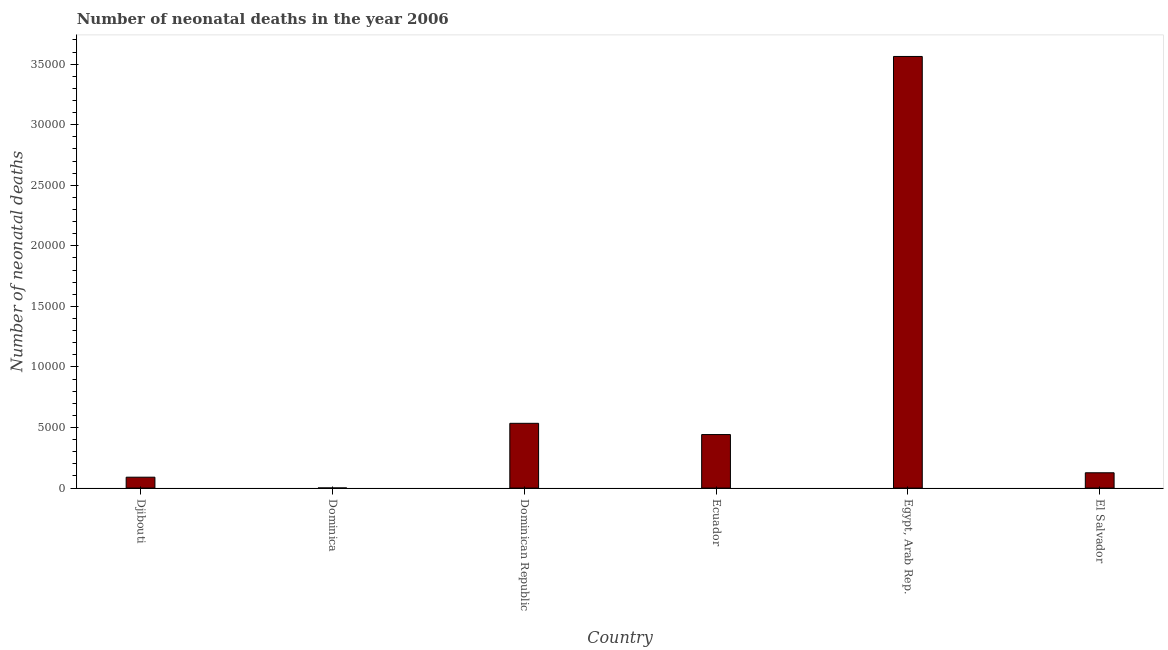Does the graph contain any zero values?
Your response must be concise. No. Does the graph contain grids?
Give a very brief answer. No. What is the title of the graph?
Your answer should be compact. Number of neonatal deaths in the year 2006. What is the label or title of the X-axis?
Make the answer very short. Country. What is the label or title of the Y-axis?
Keep it short and to the point. Number of neonatal deaths. What is the number of neonatal deaths in Dominican Republic?
Your answer should be compact. 5347. Across all countries, what is the maximum number of neonatal deaths?
Keep it short and to the point. 3.56e+04. Across all countries, what is the minimum number of neonatal deaths?
Give a very brief answer. 11. In which country was the number of neonatal deaths maximum?
Make the answer very short. Egypt, Arab Rep. In which country was the number of neonatal deaths minimum?
Offer a terse response. Dominica. What is the sum of the number of neonatal deaths?
Give a very brief answer. 4.76e+04. What is the difference between the number of neonatal deaths in Ecuador and Egypt, Arab Rep.?
Ensure brevity in your answer.  -3.12e+04. What is the average number of neonatal deaths per country?
Keep it short and to the point. 7929. What is the median number of neonatal deaths?
Your response must be concise. 2842.5. What is the ratio of the number of neonatal deaths in Dominican Republic to that in El Salvador?
Make the answer very short. 4.23. What is the difference between the highest and the second highest number of neonatal deaths?
Give a very brief answer. 3.03e+04. Is the sum of the number of neonatal deaths in Ecuador and Egypt, Arab Rep. greater than the maximum number of neonatal deaths across all countries?
Make the answer very short. Yes. What is the difference between the highest and the lowest number of neonatal deaths?
Your response must be concise. 3.56e+04. How many countries are there in the graph?
Ensure brevity in your answer.  6. What is the Number of neonatal deaths of Djibouti?
Your answer should be compact. 899. What is the Number of neonatal deaths in Dominica?
Offer a terse response. 11. What is the Number of neonatal deaths of Dominican Republic?
Ensure brevity in your answer.  5347. What is the Number of neonatal deaths of Ecuador?
Your response must be concise. 4420. What is the Number of neonatal deaths in Egypt, Arab Rep.?
Ensure brevity in your answer.  3.56e+04. What is the Number of neonatal deaths in El Salvador?
Keep it short and to the point. 1265. What is the difference between the Number of neonatal deaths in Djibouti and Dominica?
Provide a succinct answer. 888. What is the difference between the Number of neonatal deaths in Djibouti and Dominican Republic?
Ensure brevity in your answer.  -4448. What is the difference between the Number of neonatal deaths in Djibouti and Ecuador?
Provide a short and direct response. -3521. What is the difference between the Number of neonatal deaths in Djibouti and Egypt, Arab Rep.?
Offer a terse response. -3.47e+04. What is the difference between the Number of neonatal deaths in Djibouti and El Salvador?
Give a very brief answer. -366. What is the difference between the Number of neonatal deaths in Dominica and Dominican Republic?
Keep it short and to the point. -5336. What is the difference between the Number of neonatal deaths in Dominica and Ecuador?
Give a very brief answer. -4409. What is the difference between the Number of neonatal deaths in Dominica and Egypt, Arab Rep.?
Your response must be concise. -3.56e+04. What is the difference between the Number of neonatal deaths in Dominica and El Salvador?
Keep it short and to the point. -1254. What is the difference between the Number of neonatal deaths in Dominican Republic and Ecuador?
Offer a very short reply. 927. What is the difference between the Number of neonatal deaths in Dominican Republic and Egypt, Arab Rep.?
Offer a very short reply. -3.03e+04. What is the difference between the Number of neonatal deaths in Dominican Republic and El Salvador?
Your answer should be compact. 4082. What is the difference between the Number of neonatal deaths in Ecuador and Egypt, Arab Rep.?
Keep it short and to the point. -3.12e+04. What is the difference between the Number of neonatal deaths in Ecuador and El Salvador?
Give a very brief answer. 3155. What is the difference between the Number of neonatal deaths in Egypt, Arab Rep. and El Salvador?
Your answer should be very brief. 3.44e+04. What is the ratio of the Number of neonatal deaths in Djibouti to that in Dominica?
Offer a very short reply. 81.73. What is the ratio of the Number of neonatal deaths in Djibouti to that in Dominican Republic?
Offer a terse response. 0.17. What is the ratio of the Number of neonatal deaths in Djibouti to that in Ecuador?
Your answer should be very brief. 0.2. What is the ratio of the Number of neonatal deaths in Djibouti to that in Egypt, Arab Rep.?
Offer a very short reply. 0.03. What is the ratio of the Number of neonatal deaths in Djibouti to that in El Salvador?
Ensure brevity in your answer.  0.71. What is the ratio of the Number of neonatal deaths in Dominica to that in Dominican Republic?
Make the answer very short. 0. What is the ratio of the Number of neonatal deaths in Dominica to that in Ecuador?
Provide a short and direct response. 0. What is the ratio of the Number of neonatal deaths in Dominica to that in Egypt, Arab Rep.?
Provide a short and direct response. 0. What is the ratio of the Number of neonatal deaths in Dominica to that in El Salvador?
Offer a very short reply. 0.01. What is the ratio of the Number of neonatal deaths in Dominican Republic to that in Ecuador?
Provide a succinct answer. 1.21. What is the ratio of the Number of neonatal deaths in Dominican Republic to that in El Salvador?
Ensure brevity in your answer.  4.23. What is the ratio of the Number of neonatal deaths in Ecuador to that in Egypt, Arab Rep.?
Make the answer very short. 0.12. What is the ratio of the Number of neonatal deaths in Ecuador to that in El Salvador?
Your response must be concise. 3.49. What is the ratio of the Number of neonatal deaths in Egypt, Arab Rep. to that in El Salvador?
Make the answer very short. 28.17. 